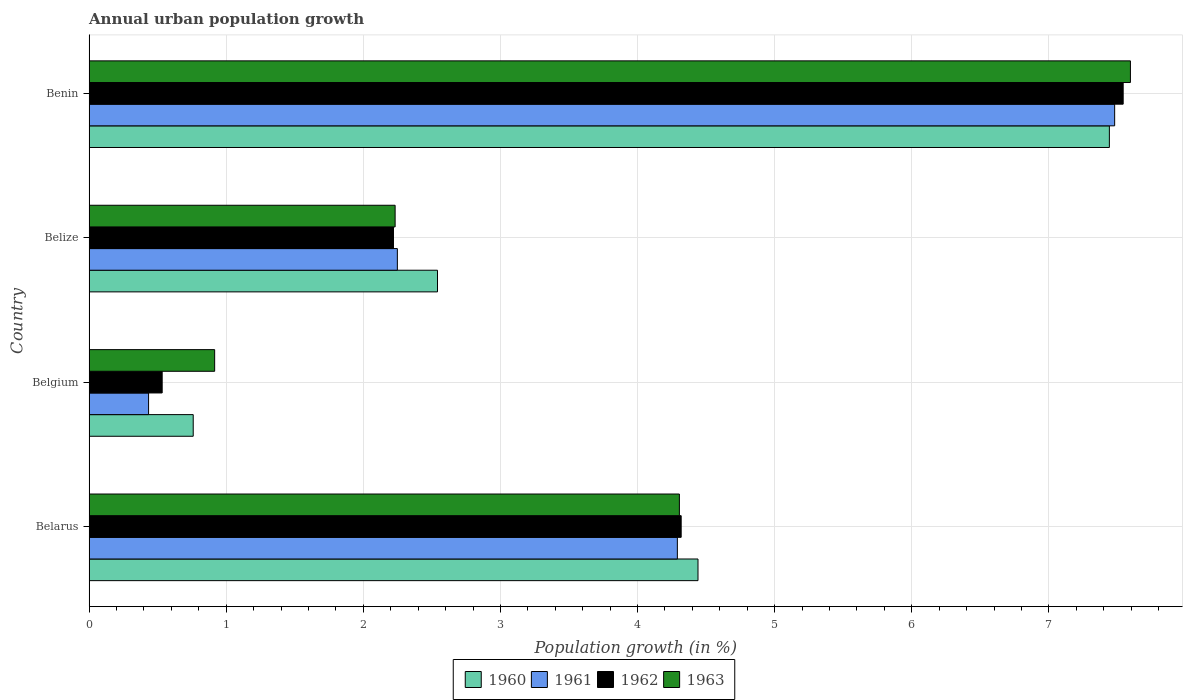How many different coloured bars are there?
Keep it short and to the point. 4. Are the number of bars per tick equal to the number of legend labels?
Provide a succinct answer. Yes. Are the number of bars on each tick of the Y-axis equal?
Provide a succinct answer. Yes. How many bars are there on the 4th tick from the bottom?
Make the answer very short. 4. What is the label of the 2nd group of bars from the top?
Your answer should be very brief. Belize. In how many cases, is the number of bars for a given country not equal to the number of legend labels?
Keep it short and to the point. 0. What is the percentage of urban population growth in 1963 in Belize?
Keep it short and to the point. 2.23. Across all countries, what is the maximum percentage of urban population growth in 1961?
Your answer should be very brief. 7.48. Across all countries, what is the minimum percentage of urban population growth in 1961?
Give a very brief answer. 0.43. In which country was the percentage of urban population growth in 1961 maximum?
Offer a very short reply. Benin. In which country was the percentage of urban population growth in 1962 minimum?
Your answer should be compact. Belgium. What is the total percentage of urban population growth in 1963 in the graph?
Offer a very short reply. 15.05. What is the difference between the percentage of urban population growth in 1963 in Belarus and that in Belgium?
Ensure brevity in your answer.  3.39. What is the difference between the percentage of urban population growth in 1963 in Belarus and the percentage of urban population growth in 1961 in Belize?
Give a very brief answer. 2.06. What is the average percentage of urban population growth in 1961 per country?
Ensure brevity in your answer.  3.61. What is the difference between the percentage of urban population growth in 1961 and percentage of urban population growth in 1960 in Belgium?
Offer a terse response. -0.33. In how many countries, is the percentage of urban population growth in 1963 greater than 3.6 %?
Make the answer very short. 2. What is the ratio of the percentage of urban population growth in 1961 in Belarus to that in Benin?
Offer a very short reply. 0.57. Is the percentage of urban population growth in 1963 in Belarus less than that in Belgium?
Your answer should be very brief. No. Is the difference between the percentage of urban population growth in 1961 in Belgium and Belize greater than the difference between the percentage of urban population growth in 1960 in Belgium and Belize?
Offer a very short reply. No. What is the difference between the highest and the second highest percentage of urban population growth in 1961?
Keep it short and to the point. 3.19. What is the difference between the highest and the lowest percentage of urban population growth in 1963?
Keep it short and to the point. 6.68. Is the sum of the percentage of urban population growth in 1961 in Belarus and Belgium greater than the maximum percentage of urban population growth in 1963 across all countries?
Your response must be concise. No. What does the 2nd bar from the top in Belize represents?
Give a very brief answer. 1962. What does the 4th bar from the bottom in Belgium represents?
Provide a short and direct response. 1963. What is the difference between two consecutive major ticks on the X-axis?
Offer a terse response. 1. Are the values on the major ticks of X-axis written in scientific E-notation?
Your response must be concise. No. Does the graph contain any zero values?
Ensure brevity in your answer.  No. Does the graph contain grids?
Offer a very short reply. Yes. How many legend labels are there?
Keep it short and to the point. 4. How are the legend labels stacked?
Provide a short and direct response. Horizontal. What is the title of the graph?
Offer a very short reply. Annual urban population growth. What is the label or title of the X-axis?
Ensure brevity in your answer.  Population growth (in %). What is the label or title of the Y-axis?
Ensure brevity in your answer.  Country. What is the Population growth (in %) of 1960 in Belarus?
Give a very brief answer. 4.44. What is the Population growth (in %) in 1961 in Belarus?
Your answer should be compact. 4.29. What is the Population growth (in %) in 1962 in Belarus?
Ensure brevity in your answer.  4.32. What is the Population growth (in %) of 1963 in Belarus?
Your response must be concise. 4.31. What is the Population growth (in %) of 1960 in Belgium?
Your answer should be very brief. 0.76. What is the Population growth (in %) in 1961 in Belgium?
Make the answer very short. 0.43. What is the Population growth (in %) of 1962 in Belgium?
Offer a terse response. 0.53. What is the Population growth (in %) of 1963 in Belgium?
Ensure brevity in your answer.  0.92. What is the Population growth (in %) of 1960 in Belize?
Your answer should be compact. 2.54. What is the Population growth (in %) of 1961 in Belize?
Ensure brevity in your answer.  2.25. What is the Population growth (in %) in 1962 in Belize?
Make the answer very short. 2.22. What is the Population growth (in %) of 1963 in Belize?
Give a very brief answer. 2.23. What is the Population growth (in %) in 1960 in Benin?
Your answer should be very brief. 7.44. What is the Population growth (in %) in 1961 in Benin?
Ensure brevity in your answer.  7.48. What is the Population growth (in %) of 1962 in Benin?
Your answer should be compact. 7.54. What is the Population growth (in %) of 1963 in Benin?
Your answer should be very brief. 7.59. Across all countries, what is the maximum Population growth (in %) in 1960?
Offer a terse response. 7.44. Across all countries, what is the maximum Population growth (in %) of 1961?
Offer a terse response. 7.48. Across all countries, what is the maximum Population growth (in %) of 1962?
Provide a short and direct response. 7.54. Across all countries, what is the maximum Population growth (in %) in 1963?
Offer a very short reply. 7.59. Across all countries, what is the minimum Population growth (in %) of 1960?
Provide a succinct answer. 0.76. Across all countries, what is the minimum Population growth (in %) of 1961?
Make the answer very short. 0.43. Across all countries, what is the minimum Population growth (in %) of 1962?
Ensure brevity in your answer.  0.53. Across all countries, what is the minimum Population growth (in %) in 1963?
Provide a short and direct response. 0.92. What is the total Population growth (in %) of 1960 in the graph?
Offer a terse response. 15.18. What is the total Population growth (in %) of 1961 in the graph?
Your answer should be very brief. 14.45. What is the total Population growth (in %) of 1962 in the graph?
Provide a succinct answer. 14.61. What is the total Population growth (in %) in 1963 in the graph?
Your answer should be very brief. 15.05. What is the difference between the Population growth (in %) in 1960 in Belarus and that in Belgium?
Ensure brevity in your answer.  3.68. What is the difference between the Population growth (in %) in 1961 in Belarus and that in Belgium?
Your answer should be very brief. 3.86. What is the difference between the Population growth (in %) in 1962 in Belarus and that in Belgium?
Ensure brevity in your answer.  3.79. What is the difference between the Population growth (in %) in 1963 in Belarus and that in Belgium?
Keep it short and to the point. 3.39. What is the difference between the Population growth (in %) of 1960 in Belarus and that in Belize?
Your answer should be very brief. 1.9. What is the difference between the Population growth (in %) in 1961 in Belarus and that in Belize?
Your answer should be very brief. 2.04. What is the difference between the Population growth (in %) of 1962 in Belarus and that in Belize?
Your answer should be very brief. 2.1. What is the difference between the Population growth (in %) in 1963 in Belarus and that in Belize?
Give a very brief answer. 2.07. What is the difference between the Population growth (in %) in 1960 in Belarus and that in Benin?
Your response must be concise. -3. What is the difference between the Population growth (in %) in 1961 in Belarus and that in Benin?
Give a very brief answer. -3.19. What is the difference between the Population growth (in %) in 1962 in Belarus and that in Benin?
Offer a terse response. -3.22. What is the difference between the Population growth (in %) of 1963 in Belarus and that in Benin?
Give a very brief answer. -3.29. What is the difference between the Population growth (in %) of 1960 in Belgium and that in Belize?
Offer a very short reply. -1.78. What is the difference between the Population growth (in %) in 1961 in Belgium and that in Belize?
Ensure brevity in your answer.  -1.81. What is the difference between the Population growth (in %) of 1962 in Belgium and that in Belize?
Your answer should be compact. -1.69. What is the difference between the Population growth (in %) of 1963 in Belgium and that in Belize?
Make the answer very short. -1.32. What is the difference between the Population growth (in %) in 1960 in Belgium and that in Benin?
Make the answer very short. -6.68. What is the difference between the Population growth (in %) in 1961 in Belgium and that in Benin?
Your response must be concise. -7.05. What is the difference between the Population growth (in %) in 1962 in Belgium and that in Benin?
Provide a succinct answer. -7.01. What is the difference between the Population growth (in %) of 1963 in Belgium and that in Benin?
Your answer should be compact. -6.68. What is the difference between the Population growth (in %) in 1960 in Belize and that in Benin?
Keep it short and to the point. -4.9. What is the difference between the Population growth (in %) of 1961 in Belize and that in Benin?
Offer a very short reply. -5.23. What is the difference between the Population growth (in %) in 1962 in Belize and that in Benin?
Ensure brevity in your answer.  -5.32. What is the difference between the Population growth (in %) in 1963 in Belize and that in Benin?
Your answer should be very brief. -5.36. What is the difference between the Population growth (in %) in 1960 in Belarus and the Population growth (in %) in 1961 in Belgium?
Offer a very short reply. 4.01. What is the difference between the Population growth (in %) of 1960 in Belarus and the Population growth (in %) of 1962 in Belgium?
Ensure brevity in your answer.  3.91. What is the difference between the Population growth (in %) of 1960 in Belarus and the Population growth (in %) of 1963 in Belgium?
Provide a succinct answer. 3.53. What is the difference between the Population growth (in %) in 1961 in Belarus and the Population growth (in %) in 1962 in Belgium?
Provide a succinct answer. 3.76. What is the difference between the Population growth (in %) in 1961 in Belarus and the Population growth (in %) in 1963 in Belgium?
Provide a succinct answer. 3.37. What is the difference between the Population growth (in %) of 1962 in Belarus and the Population growth (in %) of 1963 in Belgium?
Your answer should be very brief. 3.4. What is the difference between the Population growth (in %) in 1960 in Belarus and the Population growth (in %) in 1961 in Belize?
Offer a terse response. 2.19. What is the difference between the Population growth (in %) of 1960 in Belarus and the Population growth (in %) of 1962 in Belize?
Your answer should be compact. 2.22. What is the difference between the Population growth (in %) in 1960 in Belarus and the Population growth (in %) in 1963 in Belize?
Keep it short and to the point. 2.21. What is the difference between the Population growth (in %) of 1961 in Belarus and the Population growth (in %) of 1962 in Belize?
Offer a very short reply. 2.07. What is the difference between the Population growth (in %) in 1961 in Belarus and the Population growth (in %) in 1963 in Belize?
Make the answer very short. 2.06. What is the difference between the Population growth (in %) in 1962 in Belarus and the Population growth (in %) in 1963 in Belize?
Make the answer very short. 2.09. What is the difference between the Population growth (in %) in 1960 in Belarus and the Population growth (in %) in 1961 in Benin?
Provide a short and direct response. -3.04. What is the difference between the Population growth (in %) in 1960 in Belarus and the Population growth (in %) in 1962 in Benin?
Your response must be concise. -3.1. What is the difference between the Population growth (in %) in 1960 in Belarus and the Population growth (in %) in 1963 in Benin?
Your response must be concise. -3.15. What is the difference between the Population growth (in %) of 1961 in Belarus and the Population growth (in %) of 1962 in Benin?
Your answer should be compact. -3.25. What is the difference between the Population growth (in %) in 1961 in Belarus and the Population growth (in %) in 1963 in Benin?
Offer a terse response. -3.3. What is the difference between the Population growth (in %) in 1962 in Belarus and the Population growth (in %) in 1963 in Benin?
Your response must be concise. -3.28. What is the difference between the Population growth (in %) in 1960 in Belgium and the Population growth (in %) in 1961 in Belize?
Your answer should be very brief. -1.49. What is the difference between the Population growth (in %) of 1960 in Belgium and the Population growth (in %) of 1962 in Belize?
Provide a succinct answer. -1.46. What is the difference between the Population growth (in %) in 1960 in Belgium and the Population growth (in %) in 1963 in Belize?
Your answer should be very brief. -1.47. What is the difference between the Population growth (in %) of 1961 in Belgium and the Population growth (in %) of 1962 in Belize?
Give a very brief answer. -1.79. What is the difference between the Population growth (in %) in 1961 in Belgium and the Population growth (in %) in 1963 in Belize?
Your answer should be compact. -1.8. What is the difference between the Population growth (in %) of 1962 in Belgium and the Population growth (in %) of 1963 in Belize?
Offer a very short reply. -1.7. What is the difference between the Population growth (in %) of 1960 in Belgium and the Population growth (in %) of 1961 in Benin?
Keep it short and to the point. -6.72. What is the difference between the Population growth (in %) of 1960 in Belgium and the Population growth (in %) of 1962 in Benin?
Your answer should be compact. -6.78. What is the difference between the Population growth (in %) of 1960 in Belgium and the Population growth (in %) of 1963 in Benin?
Make the answer very short. -6.84. What is the difference between the Population growth (in %) in 1961 in Belgium and the Population growth (in %) in 1962 in Benin?
Provide a short and direct response. -7.11. What is the difference between the Population growth (in %) in 1961 in Belgium and the Population growth (in %) in 1963 in Benin?
Your response must be concise. -7.16. What is the difference between the Population growth (in %) of 1962 in Belgium and the Population growth (in %) of 1963 in Benin?
Your answer should be very brief. -7.06. What is the difference between the Population growth (in %) in 1960 in Belize and the Population growth (in %) in 1961 in Benin?
Your answer should be very brief. -4.94. What is the difference between the Population growth (in %) in 1960 in Belize and the Population growth (in %) in 1962 in Benin?
Make the answer very short. -5. What is the difference between the Population growth (in %) of 1960 in Belize and the Population growth (in %) of 1963 in Benin?
Make the answer very short. -5.05. What is the difference between the Population growth (in %) of 1961 in Belize and the Population growth (in %) of 1962 in Benin?
Your response must be concise. -5.29. What is the difference between the Population growth (in %) of 1961 in Belize and the Population growth (in %) of 1963 in Benin?
Provide a succinct answer. -5.35. What is the difference between the Population growth (in %) in 1962 in Belize and the Population growth (in %) in 1963 in Benin?
Offer a terse response. -5.37. What is the average Population growth (in %) of 1960 per country?
Your response must be concise. 3.8. What is the average Population growth (in %) of 1961 per country?
Give a very brief answer. 3.61. What is the average Population growth (in %) of 1962 per country?
Your answer should be compact. 3.65. What is the average Population growth (in %) in 1963 per country?
Your response must be concise. 3.76. What is the difference between the Population growth (in %) in 1960 and Population growth (in %) in 1961 in Belarus?
Ensure brevity in your answer.  0.15. What is the difference between the Population growth (in %) in 1960 and Population growth (in %) in 1962 in Belarus?
Ensure brevity in your answer.  0.12. What is the difference between the Population growth (in %) in 1960 and Population growth (in %) in 1963 in Belarus?
Your answer should be compact. 0.14. What is the difference between the Population growth (in %) in 1961 and Population growth (in %) in 1962 in Belarus?
Your response must be concise. -0.03. What is the difference between the Population growth (in %) in 1961 and Population growth (in %) in 1963 in Belarus?
Your answer should be compact. -0.01. What is the difference between the Population growth (in %) in 1962 and Population growth (in %) in 1963 in Belarus?
Give a very brief answer. 0.01. What is the difference between the Population growth (in %) of 1960 and Population growth (in %) of 1961 in Belgium?
Offer a terse response. 0.33. What is the difference between the Population growth (in %) of 1960 and Population growth (in %) of 1962 in Belgium?
Offer a terse response. 0.23. What is the difference between the Population growth (in %) in 1960 and Population growth (in %) in 1963 in Belgium?
Make the answer very short. -0.16. What is the difference between the Population growth (in %) in 1961 and Population growth (in %) in 1962 in Belgium?
Keep it short and to the point. -0.1. What is the difference between the Population growth (in %) in 1961 and Population growth (in %) in 1963 in Belgium?
Your response must be concise. -0.48. What is the difference between the Population growth (in %) in 1962 and Population growth (in %) in 1963 in Belgium?
Your answer should be very brief. -0.38. What is the difference between the Population growth (in %) in 1960 and Population growth (in %) in 1961 in Belize?
Your response must be concise. 0.29. What is the difference between the Population growth (in %) of 1960 and Population growth (in %) of 1962 in Belize?
Offer a terse response. 0.32. What is the difference between the Population growth (in %) of 1960 and Population growth (in %) of 1963 in Belize?
Your response must be concise. 0.31. What is the difference between the Population growth (in %) of 1961 and Population growth (in %) of 1962 in Belize?
Offer a very short reply. 0.03. What is the difference between the Population growth (in %) of 1961 and Population growth (in %) of 1963 in Belize?
Your answer should be very brief. 0.02. What is the difference between the Population growth (in %) in 1962 and Population growth (in %) in 1963 in Belize?
Your response must be concise. -0.01. What is the difference between the Population growth (in %) in 1960 and Population growth (in %) in 1961 in Benin?
Keep it short and to the point. -0.04. What is the difference between the Population growth (in %) in 1960 and Population growth (in %) in 1962 in Benin?
Offer a very short reply. -0.1. What is the difference between the Population growth (in %) in 1960 and Population growth (in %) in 1963 in Benin?
Make the answer very short. -0.15. What is the difference between the Population growth (in %) of 1961 and Population growth (in %) of 1962 in Benin?
Your answer should be compact. -0.06. What is the difference between the Population growth (in %) of 1961 and Population growth (in %) of 1963 in Benin?
Your response must be concise. -0.12. What is the difference between the Population growth (in %) in 1962 and Population growth (in %) in 1963 in Benin?
Your response must be concise. -0.05. What is the ratio of the Population growth (in %) in 1960 in Belarus to that in Belgium?
Offer a very short reply. 5.85. What is the ratio of the Population growth (in %) of 1961 in Belarus to that in Belgium?
Your answer should be compact. 9.89. What is the ratio of the Population growth (in %) in 1962 in Belarus to that in Belgium?
Provide a short and direct response. 8.1. What is the ratio of the Population growth (in %) in 1963 in Belarus to that in Belgium?
Provide a succinct answer. 4.7. What is the ratio of the Population growth (in %) in 1960 in Belarus to that in Belize?
Offer a terse response. 1.75. What is the ratio of the Population growth (in %) in 1961 in Belarus to that in Belize?
Give a very brief answer. 1.91. What is the ratio of the Population growth (in %) of 1962 in Belarus to that in Belize?
Keep it short and to the point. 1.95. What is the ratio of the Population growth (in %) of 1963 in Belarus to that in Belize?
Your response must be concise. 1.93. What is the ratio of the Population growth (in %) of 1960 in Belarus to that in Benin?
Your answer should be compact. 0.6. What is the ratio of the Population growth (in %) of 1961 in Belarus to that in Benin?
Your response must be concise. 0.57. What is the ratio of the Population growth (in %) in 1962 in Belarus to that in Benin?
Your answer should be compact. 0.57. What is the ratio of the Population growth (in %) of 1963 in Belarus to that in Benin?
Give a very brief answer. 0.57. What is the ratio of the Population growth (in %) in 1960 in Belgium to that in Belize?
Keep it short and to the point. 0.3. What is the ratio of the Population growth (in %) of 1961 in Belgium to that in Belize?
Give a very brief answer. 0.19. What is the ratio of the Population growth (in %) of 1962 in Belgium to that in Belize?
Provide a succinct answer. 0.24. What is the ratio of the Population growth (in %) of 1963 in Belgium to that in Belize?
Make the answer very short. 0.41. What is the ratio of the Population growth (in %) in 1960 in Belgium to that in Benin?
Keep it short and to the point. 0.1. What is the ratio of the Population growth (in %) in 1961 in Belgium to that in Benin?
Your answer should be very brief. 0.06. What is the ratio of the Population growth (in %) in 1962 in Belgium to that in Benin?
Keep it short and to the point. 0.07. What is the ratio of the Population growth (in %) of 1963 in Belgium to that in Benin?
Your answer should be compact. 0.12. What is the ratio of the Population growth (in %) of 1960 in Belize to that in Benin?
Offer a terse response. 0.34. What is the ratio of the Population growth (in %) of 1961 in Belize to that in Benin?
Your answer should be compact. 0.3. What is the ratio of the Population growth (in %) of 1962 in Belize to that in Benin?
Your answer should be very brief. 0.29. What is the ratio of the Population growth (in %) of 1963 in Belize to that in Benin?
Ensure brevity in your answer.  0.29. What is the difference between the highest and the second highest Population growth (in %) in 1960?
Offer a terse response. 3. What is the difference between the highest and the second highest Population growth (in %) in 1961?
Give a very brief answer. 3.19. What is the difference between the highest and the second highest Population growth (in %) in 1962?
Your response must be concise. 3.22. What is the difference between the highest and the second highest Population growth (in %) of 1963?
Offer a very short reply. 3.29. What is the difference between the highest and the lowest Population growth (in %) in 1960?
Your answer should be compact. 6.68. What is the difference between the highest and the lowest Population growth (in %) in 1961?
Provide a short and direct response. 7.05. What is the difference between the highest and the lowest Population growth (in %) of 1962?
Ensure brevity in your answer.  7.01. What is the difference between the highest and the lowest Population growth (in %) in 1963?
Offer a very short reply. 6.68. 